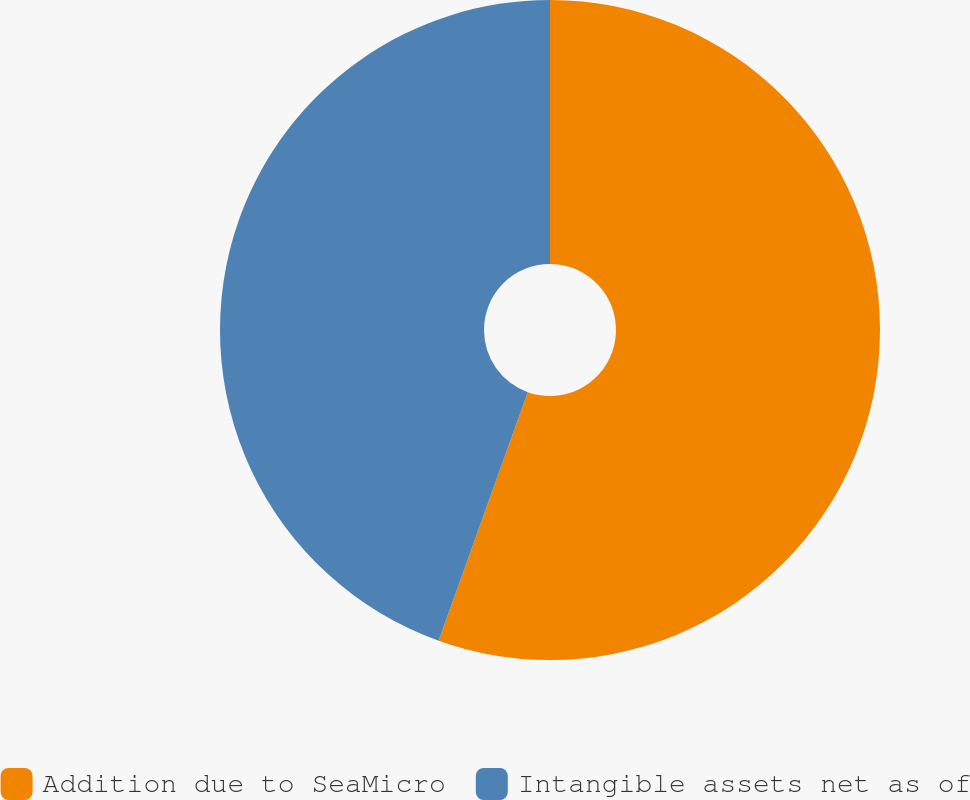Convert chart. <chart><loc_0><loc_0><loc_500><loc_500><pie_chart><fcel>Addition due to SeaMicro<fcel>Intangible assets net as of<nl><fcel>55.48%<fcel>44.52%<nl></chart> 